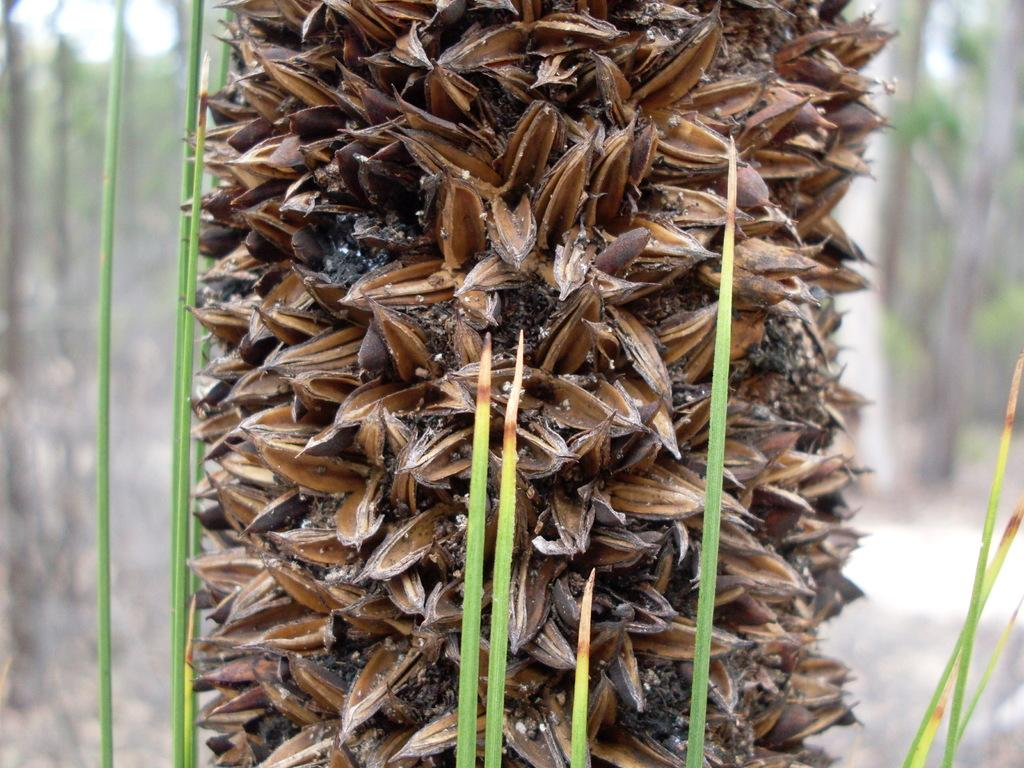What type of plant can be seen in the image? There is a tree in the image. What type of vegetation is present at the base of the tree? There is grass in the image. What degree does the tree have in the image? The tree does not have a degree in the image, as degrees are not applicable to trees. What type of pin can be seen holding the grass together in the image? There is no pin present in the image; the grass is not held together by any pin. 